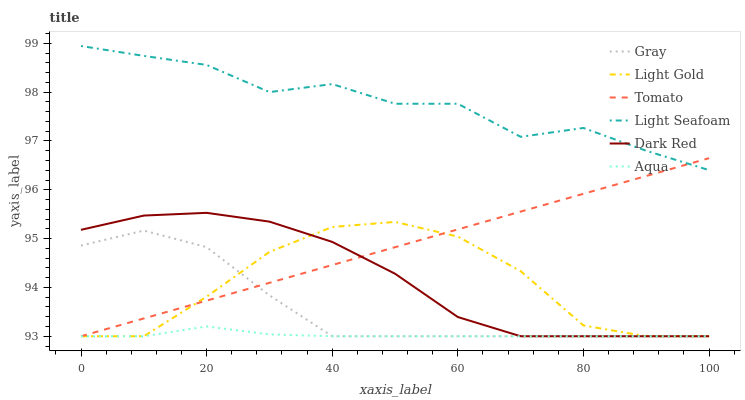Does Aqua have the minimum area under the curve?
Answer yes or no. Yes. Does Light Seafoam have the maximum area under the curve?
Answer yes or no. Yes. Does Gray have the minimum area under the curve?
Answer yes or no. No. Does Gray have the maximum area under the curve?
Answer yes or no. No. Is Tomato the smoothest?
Answer yes or no. Yes. Is Light Seafoam the roughest?
Answer yes or no. Yes. Is Gray the smoothest?
Answer yes or no. No. Is Gray the roughest?
Answer yes or no. No. Does Tomato have the lowest value?
Answer yes or no. Yes. Does Light Seafoam have the lowest value?
Answer yes or no. No. Does Light Seafoam have the highest value?
Answer yes or no. Yes. Does Gray have the highest value?
Answer yes or no. No. Is Aqua less than Light Seafoam?
Answer yes or no. Yes. Is Light Seafoam greater than Gray?
Answer yes or no. Yes. Does Dark Red intersect Gray?
Answer yes or no. Yes. Is Dark Red less than Gray?
Answer yes or no. No. Is Dark Red greater than Gray?
Answer yes or no. No. Does Aqua intersect Light Seafoam?
Answer yes or no. No. 